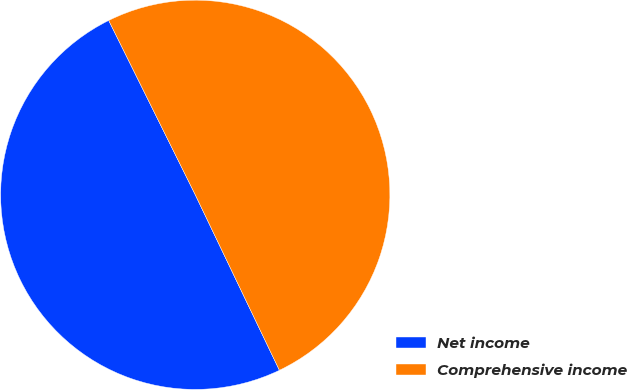Convert chart. <chart><loc_0><loc_0><loc_500><loc_500><pie_chart><fcel>Net income<fcel>Comprehensive income<nl><fcel>49.78%<fcel>50.22%<nl></chart> 